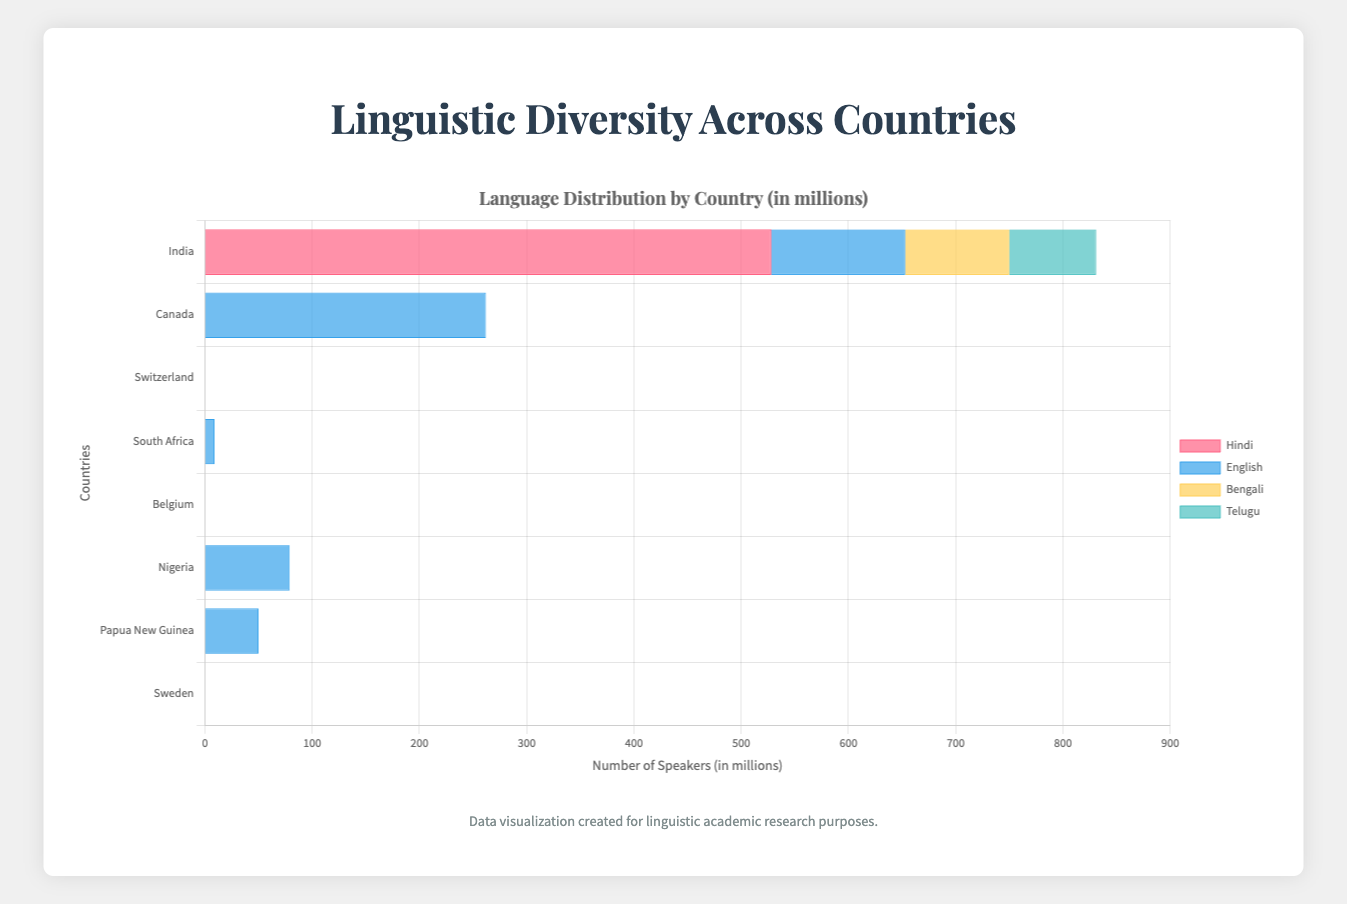Which country has the highest number of Hindi speakers? The chart shows that India has the highest number of Hindi speakers with a noticeable bar height representing 528 million speakers.
Answer: India What is the total number of language speakers in Nigeria represented in the chart? Add the counts of all languages spoken in Nigeria (English: 79, Hausa: 52, Yoruba: 40, Igbo: 30). Total = 79 + 52 + 40 + 30 = 201 million.
Answer: 201 Which language has the second most speakers in Canada? The chart presents English as the most spoken language in Canada, followed by French with 75 million speakers.
Answer: French How does the number of Bengali speakers in India compare to the number of Swedish speakers in Sweden? Compare the counts for Bengali speakers in India (97 million) and Swedish speakers in Sweden (85 million). Bengali has more speakers than Swedish.
Answer: Bengali What is the sum of French speakers in Canada, Belgium, and Switzerland? Add the number of French speakers in each country: Canada (75), Belgium (40), and Switzerland (23). Total = 75 + 40 + 23 = 138 million.
Answer: 138 Which country has the least number of Spanish speakers and what is the count? By examining the bars for each country, Canada has the least number of Spanish speakers with 9 million.
Answer: Canada, 9 What is the average number of speakers for Dutch, French, and German in Belgium? Sum the counts for each language (Dutch: 59, French: 40, German: 1) and divide by the number of languages. Average = (59 + 40 + 1) / 3 = 33.33 million.
Answer: 33.33 Does Nigeria have more English speakers than Canada? Compare the English speakers count in Nigeria (79 million) and Canada (262 million). Nigeria has fewer English speakers than Canada.
Answer: No What is the total number of official languages represented in Switzerland? The chart lists four languages for Switzerland: German, French, Italian, and Romansh. Count = 4.
Answer: 4 How does the number of Zulu speakers in South Africa compare to the number of Hindi speakers in India? Compare counts: Zulu (27 million) and Hindi (528 million). Hindi has significantly more speakers than Zulu.
Answer: Hindi 